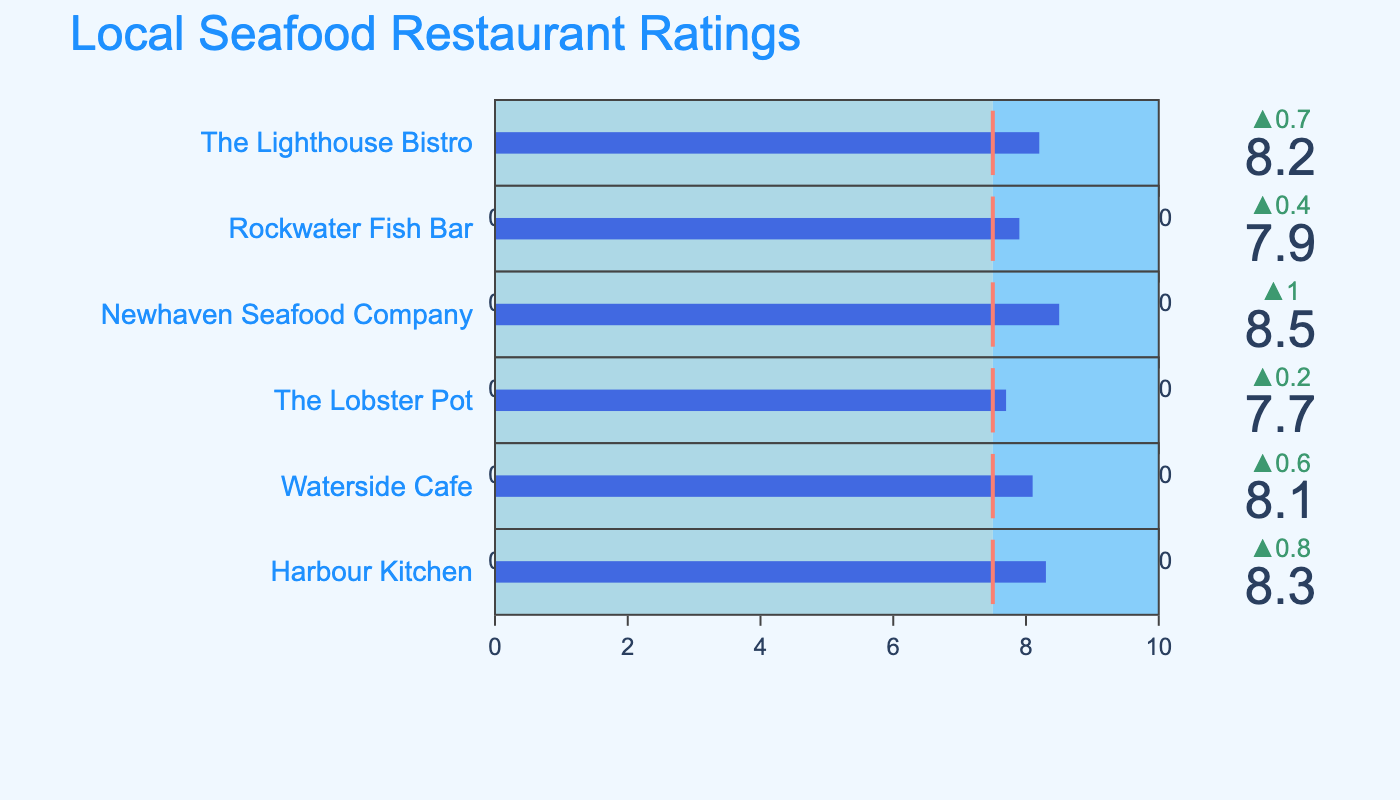How many restaurants are listed in the figure? Count the number of bullet charts representing individual restaurants. There are 6 bullet charts, each representing a different restaurant.
Answer: 6 What's the title of the figure? The title is displayed at the top of the figure, indicating what the chart is about. The title text reads "Local Seafood Restaurant Ratings".
Answer: Local Seafood Restaurant Ratings Which restaurant has the highest rating? Look at the value on each bullet chart to identify the highest one. "Newhaven Seafood Company" has the highest rating of 8.5.
Answer: Newhaven Seafood Company Which rating is closest to the benchmark? Compare the ratings to the benchmark of 7.5 and find the closest one. "Rockwater Fish Bar" with a rating of 7.9 is the closest to the benchmark of 7.5.
Answer: Rockwater Fish Bar What's the average rating of all the restaurants? Calculate the sum of all ratings and then divide by the number of restaurants. The sum is (8.2 + 7.9 + 8.5 + 7.7 + 8.1 + 8.3) = 48.7. The average is 48.7 / 6 = 8.12.
Answer: 8.12 Which restaurant has the biggest difference between its rating and the benchmark? Subtract the benchmark (7.5) from each rating and find the largest difference. The ratings and differences are: 
- The Lighthouse Bistro: 8.2 - 7.5 = 0.7
- Rockwater Fish Bar: 7.9 - 7.5 = 0.4
- Newhaven Seafood Company: 8.5 - 7.5 = 1.0
- The Lobster Pot: 7.7 - 7.5 = 0.2
- Waterside Cafe: 8.1 - 7.5 = 0.6
- Harbour Kitchen: 8.3 - 7.5 = 0.8 
Newhaven Seafood Company has the largest difference.
Answer: Newhaven Seafood Company How many restaurants have ratings above the benchmark? Count the number of ratings that are above the benchmark of 7.5. All 6 restaurants (8.2, 7.9, 8.5, 7.7, 8.1, and 8.3) are above the benchmark.
Answer: 6 Which restaurant's rating bar is the longest? The rating bars correspond to the actual ratings out of 10. The longest bar will be the one with the highest rating. "Newhaven Seafood Company" has the highest rating of 8.5, so it has the longest bar.
Answer: Newhaven Seafood Company 